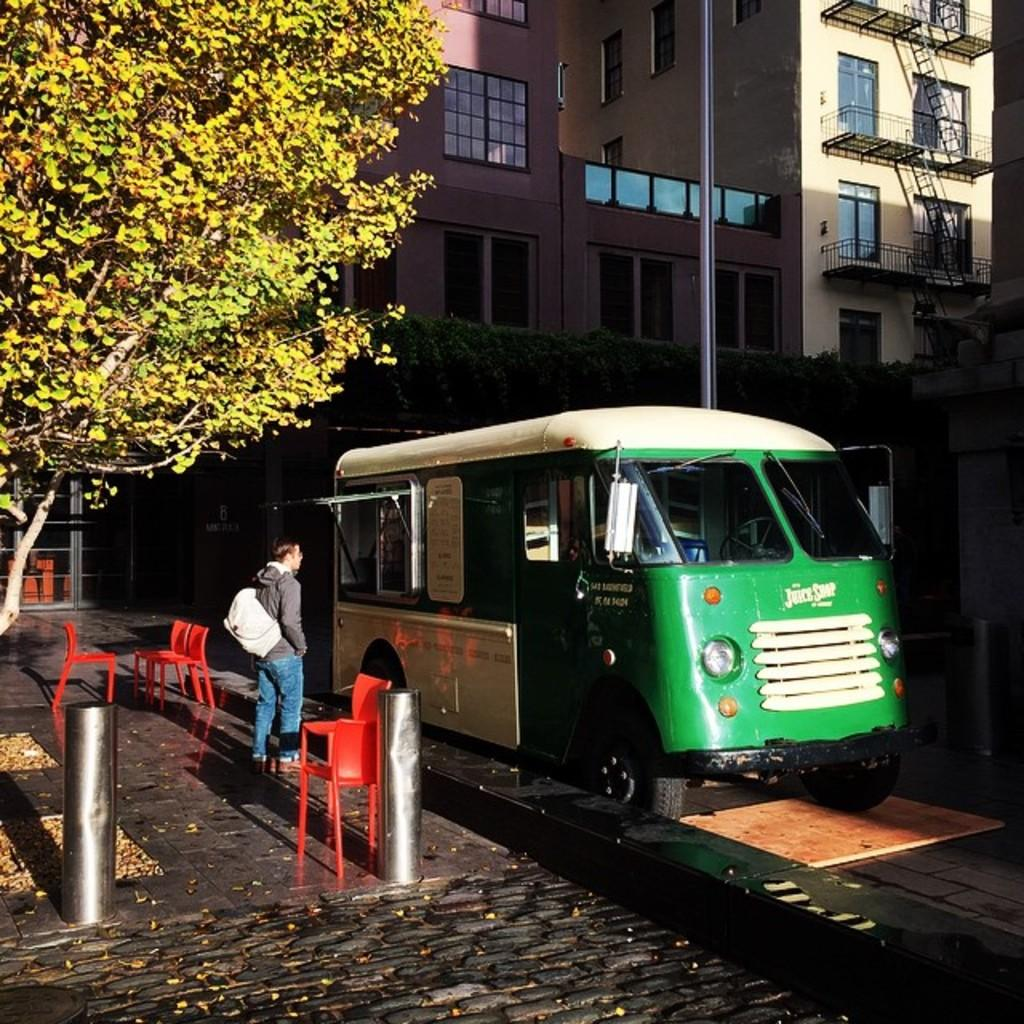What is located on the left side of the image? There is a tree on the left side of the image. What can be seen on the right side of the image? There is a minibus on the right side of the image. What structures are in the middle of the image? There are buildings in the middle of the image. What is the man in the middle of the image doing? The man is standing in the middle of the image with a bag. What type of polish is the man applying to the tree in the image? There is no indication in the image that the man is applying any polish to the tree. What type of wood is the minibus made of in the image? The image does not provide information about the material the minibus is made of. 